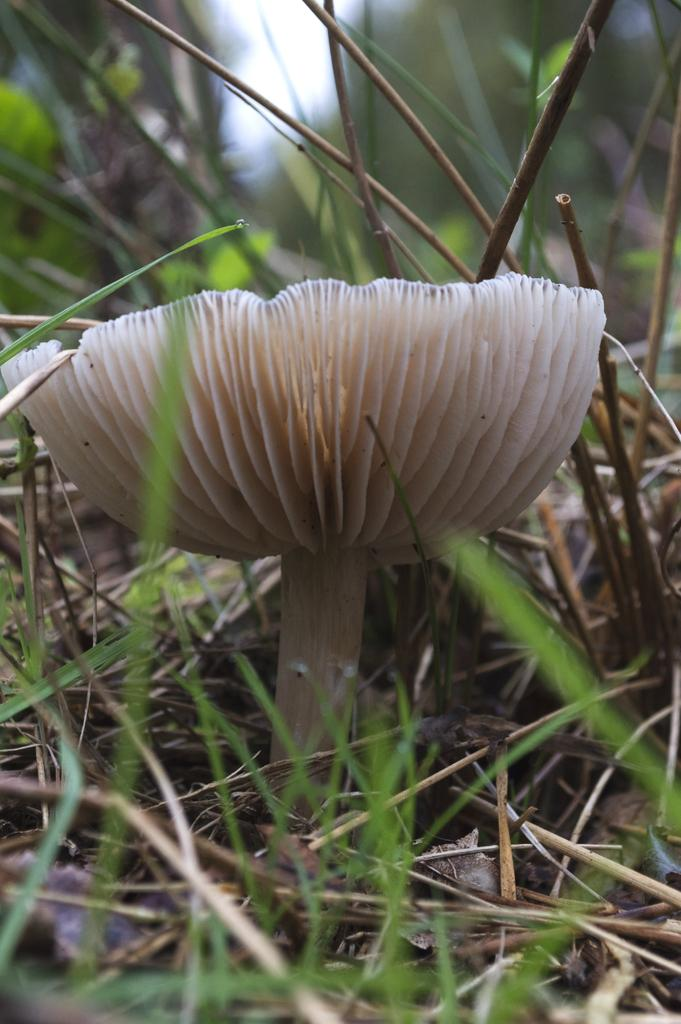What is the main subject of the image? The main subject of the image is a mushroom. What type of vegetation is present around the mushroom? There is grass surrounding the mushroom. Can you describe the background of the image? The background of the image is blurred. What type of basin is visible in the image? There is no basin present in the image. What industry can be seen in the background of the image? The background of the image is blurred, and there is no indication of an industry. 